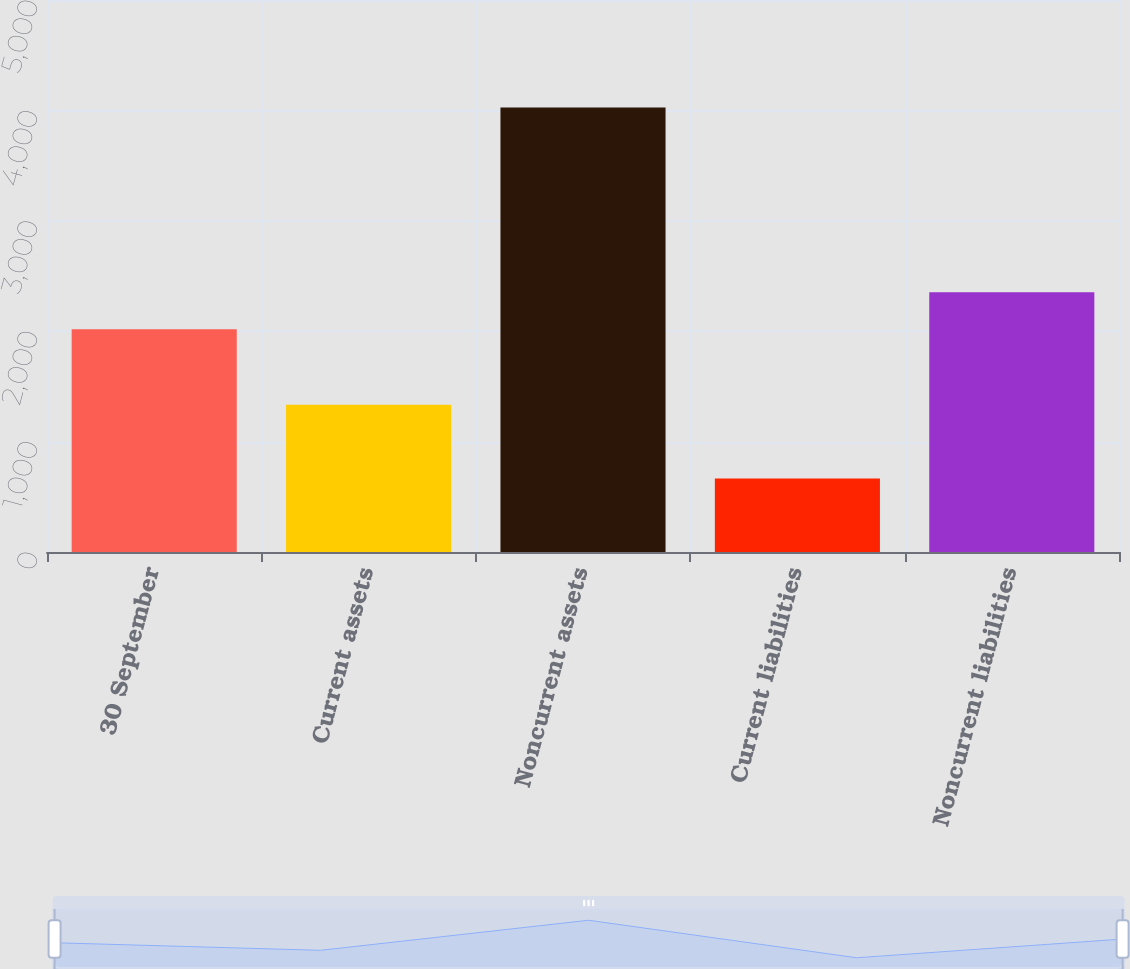Convert chart. <chart><loc_0><loc_0><loc_500><loc_500><bar_chart><fcel>30 September<fcel>Current assets<fcel>Noncurrent assets<fcel>Current liabilities<fcel>Noncurrent liabilities<nl><fcel>2017<fcel>1333.2<fcel>4026.9<fcel>666.8<fcel>2353.01<nl></chart> 